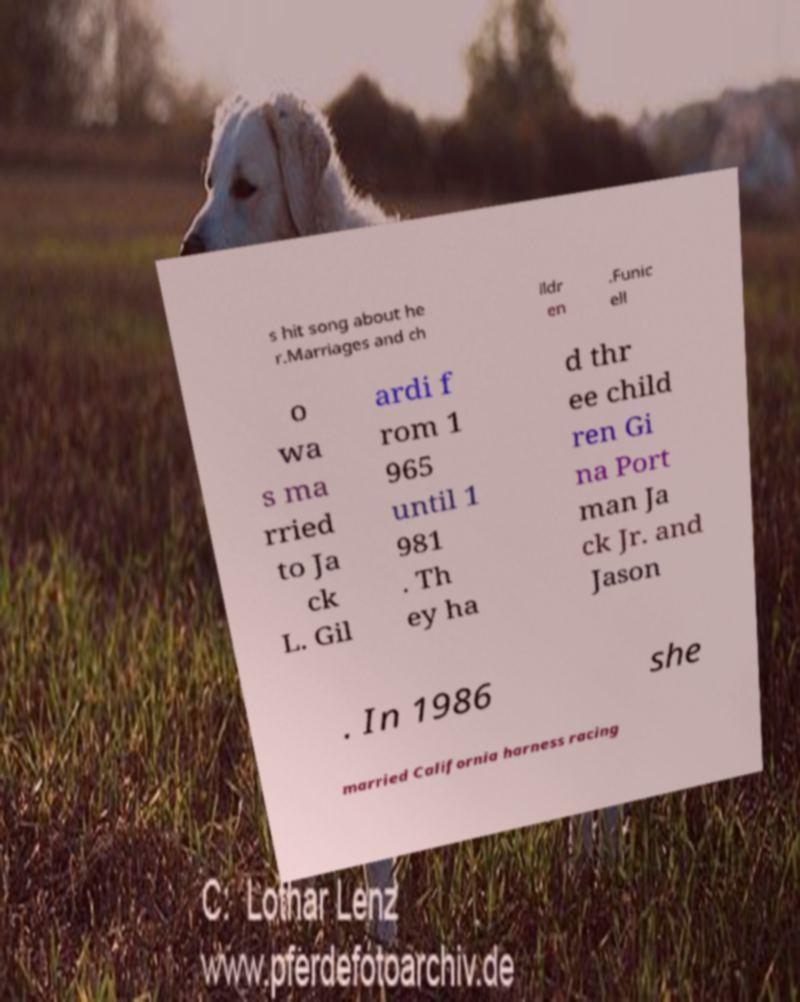Can you read and provide the text displayed in the image?This photo seems to have some interesting text. Can you extract and type it out for me? s hit song about he r.Marriages and ch ildr en .Funic ell o wa s ma rried to Ja ck L. Gil ardi f rom 1 965 until 1 981 . Th ey ha d thr ee child ren Gi na Port man Ja ck Jr. and Jason . In 1986 she married California harness racing 